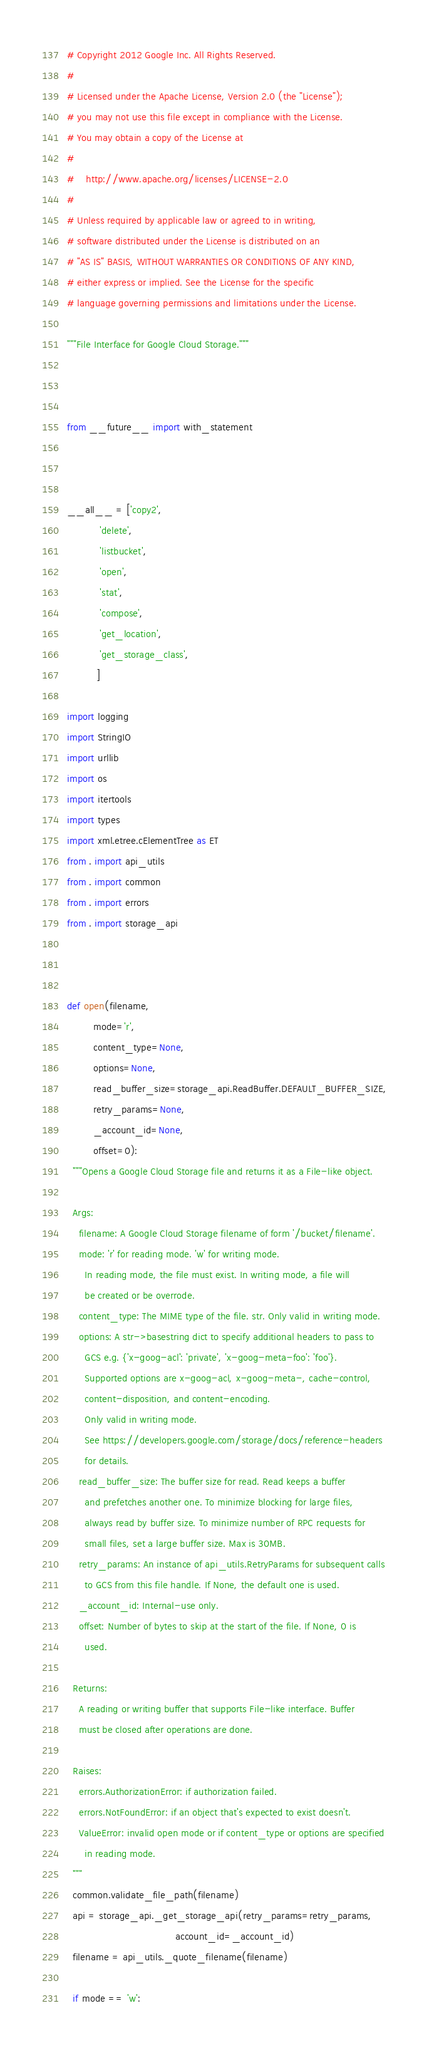Convert code to text. <code><loc_0><loc_0><loc_500><loc_500><_Python_># Copyright 2012 Google Inc. All Rights Reserved.
#
# Licensed under the Apache License, Version 2.0 (the "License");
# you may not use this file except in compliance with the License.
# You may obtain a copy of the License at
#
#    http://www.apache.org/licenses/LICENSE-2.0
#
# Unless required by applicable law or agreed to in writing,
# software distributed under the License is distributed on an
# "AS IS" BASIS, WITHOUT WARRANTIES OR CONDITIONS OF ANY KIND,
# either express or implied. See the License for the specific
# language governing permissions and limitations under the License.

"""File Interface for Google Cloud Storage."""



from __future__ import with_statement



__all__ = ['copy2',
           'delete',
           'listbucket',
           'open',
           'stat',
           'compose',
           'get_location',
           'get_storage_class',
          ]

import logging
import StringIO
import urllib
import os
import itertools
import types
import xml.etree.cElementTree as ET
from . import api_utils
from . import common
from . import errors
from . import storage_api



def open(filename,
         mode='r',
         content_type=None,
         options=None,
         read_buffer_size=storage_api.ReadBuffer.DEFAULT_BUFFER_SIZE,
         retry_params=None,
         _account_id=None,
         offset=0):
  """Opens a Google Cloud Storage file and returns it as a File-like object.

  Args:
    filename: A Google Cloud Storage filename of form '/bucket/filename'.
    mode: 'r' for reading mode. 'w' for writing mode.
      In reading mode, the file must exist. In writing mode, a file will
      be created or be overrode.
    content_type: The MIME type of the file. str. Only valid in writing mode.
    options: A str->basestring dict to specify additional headers to pass to
      GCS e.g. {'x-goog-acl': 'private', 'x-goog-meta-foo': 'foo'}.
      Supported options are x-goog-acl, x-goog-meta-, cache-control,
      content-disposition, and content-encoding.
      Only valid in writing mode.
      See https://developers.google.com/storage/docs/reference-headers
      for details.
    read_buffer_size: The buffer size for read. Read keeps a buffer
      and prefetches another one. To minimize blocking for large files,
      always read by buffer size. To minimize number of RPC requests for
      small files, set a large buffer size. Max is 30MB.
    retry_params: An instance of api_utils.RetryParams for subsequent calls
      to GCS from this file handle. If None, the default one is used.
    _account_id: Internal-use only.
    offset: Number of bytes to skip at the start of the file. If None, 0 is
      used.

  Returns:
    A reading or writing buffer that supports File-like interface. Buffer
    must be closed after operations are done.

  Raises:
    errors.AuthorizationError: if authorization failed.
    errors.NotFoundError: if an object that's expected to exist doesn't.
    ValueError: invalid open mode or if content_type or options are specified
      in reading mode.
  """
  common.validate_file_path(filename)
  api = storage_api._get_storage_api(retry_params=retry_params,
                                     account_id=_account_id)
  filename = api_utils._quote_filename(filename)

  if mode == 'w':</code> 